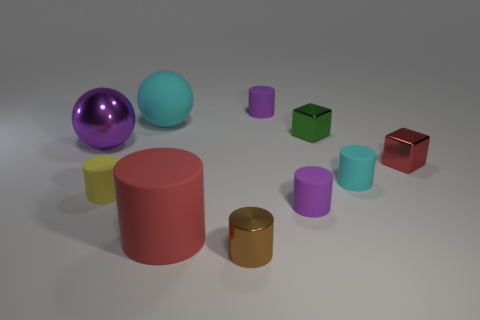Do the tiny brown thing and the tiny purple cylinder that is behind the tiny green metallic thing have the same material? Upon examining the image, it appears that the brown and purple objects have different finishes and reflect light differently, suggesting distinct materials. The brown object seems to have a matte finish, while the purple cylinder has a slightly shiny surface, indicating they are not made of the same material. 